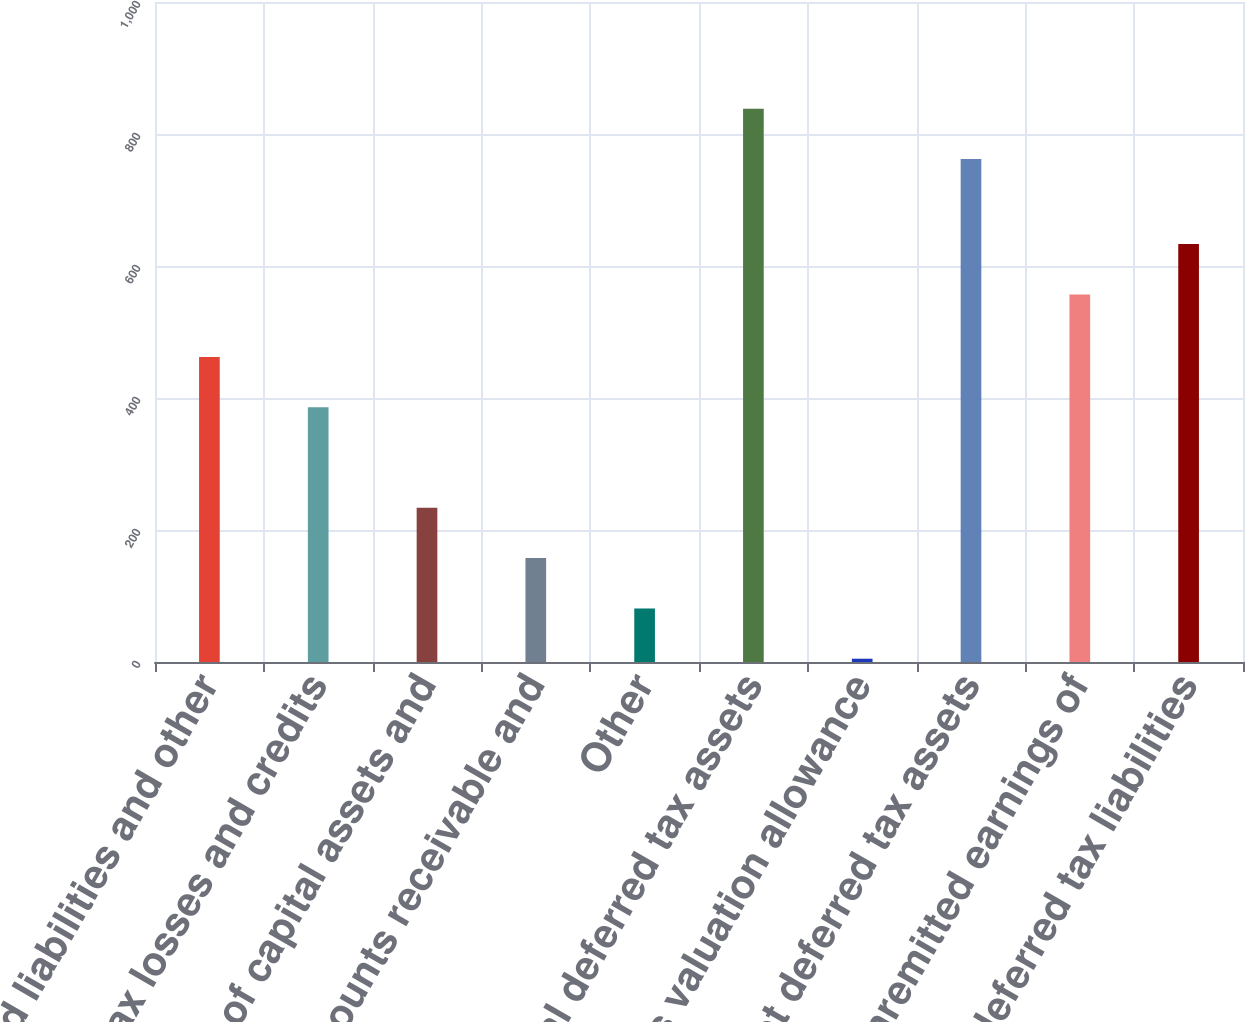Convert chart. <chart><loc_0><loc_0><loc_500><loc_500><bar_chart><fcel>Accrued liabilities and other<fcel>Tax losses and credits<fcel>Basis of capital assets and<fcel>Accounts receivable and<fcel>Other<fcel>Total deferred tax assets<fcel>Less valuation allowance<fcel>Net deferred tax assets<fcel>Unremitted earnings of<fcel>Total deferred tax liabilities<nl><fcel>462.2<fcel>386<fcel>233.6<fcel>157.4<fcel>81.2<fcel>838.2<fcel>5<fcel>762<fcel>557<fcel>633.2<nl></chart> 